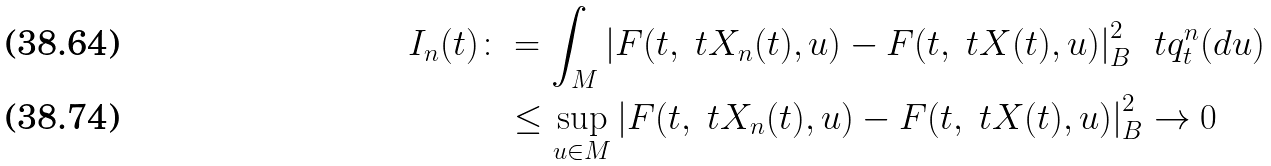Convert formula to latex. <formula><loc_0><loc_0><loc_500><loc_500>I _ { n } ( t ) \colon & = \int _ { M } \left | F ( t , \ t X _ { n } ( t ) , u ) - F ( t , \ t X ( t ) , u ) \right | _ { B } ^ { 2 } \, \ t q ^ { n } _ { t } ( d u ) \\ & \leq \sup _ { u \in M } \left | F ( t , \ t X _ { n } ( t ) , u ) - F ( t , \ t X ( t ) , u ) \right | _ { B } ^ { 2 } \to 0</formula> 